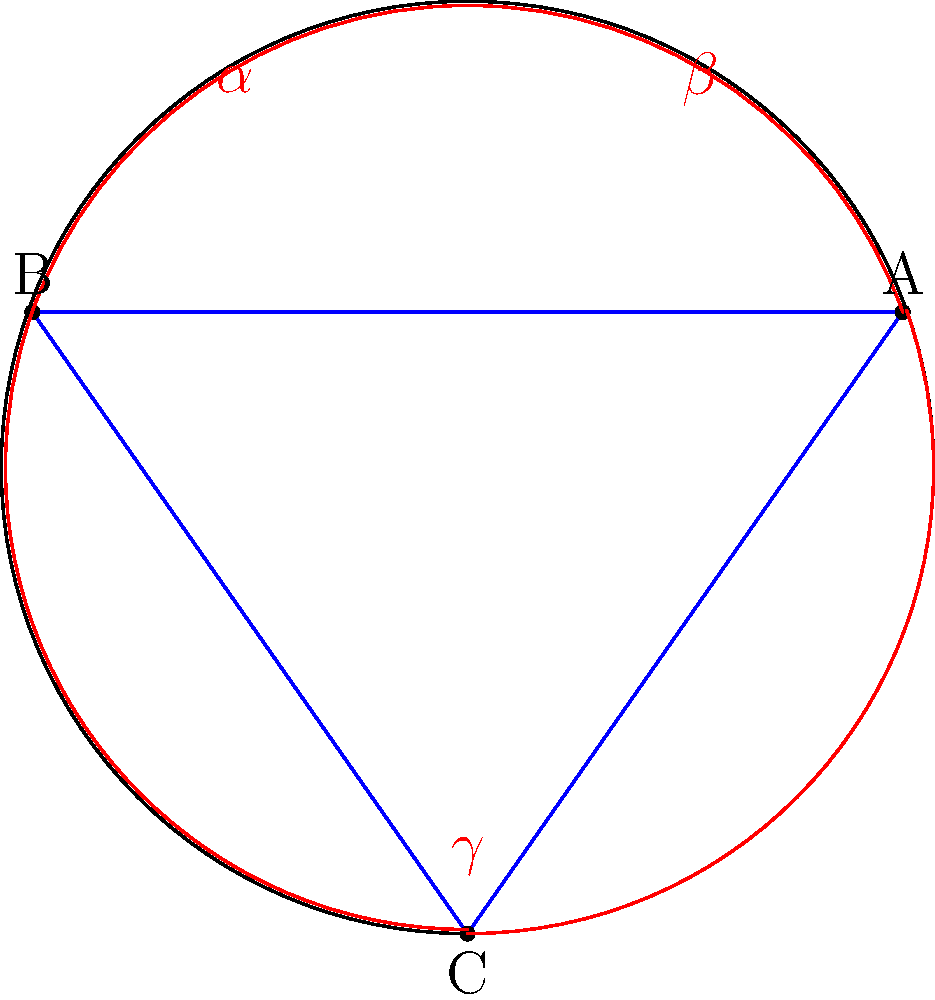As a tech startup founder familiar with innovative spatial technologies, consider a spherical surface representing a planet or a virtual reality environment. On this surface, a triangle ABC is drawn with angles $\alpha$, $\beta$, and $\gamma$. Unlike in Euclidean geometry, the sum of these angles exceeds 180°. If the excess angle (the amount by which the sum exceeds 180°) is 30°, what is the area of this spherical triangle in terms of $R^2$, where R is the radius of the sphere? Let's approach this step-by-step:

1) In spherical geometry, the sum of angles in a triangle is greater than 180°. The difference between this sum and 180° is called the spherical excess.

2) Given: The spherical excess is 30° or $\frac{\pi}{6}$ radians.

3) The Girard's Theorem states that the area A of a spherical triangle is:

   $$A = R^2 \cdot E$$

   Where R is the radius of the sphere and E is the spherical excess in radians.

4) We know the spherical excess E = 30° = $\frac{\pi}{6}$ radians.

5) Substituting this into Girard's Theorem:

   $$A = R^2 \cdot \frac{\pi}{6}$$

6) This gives us the area in terms of $R^2$.
Answer: $\frac{\pi}{6}R^2$ 